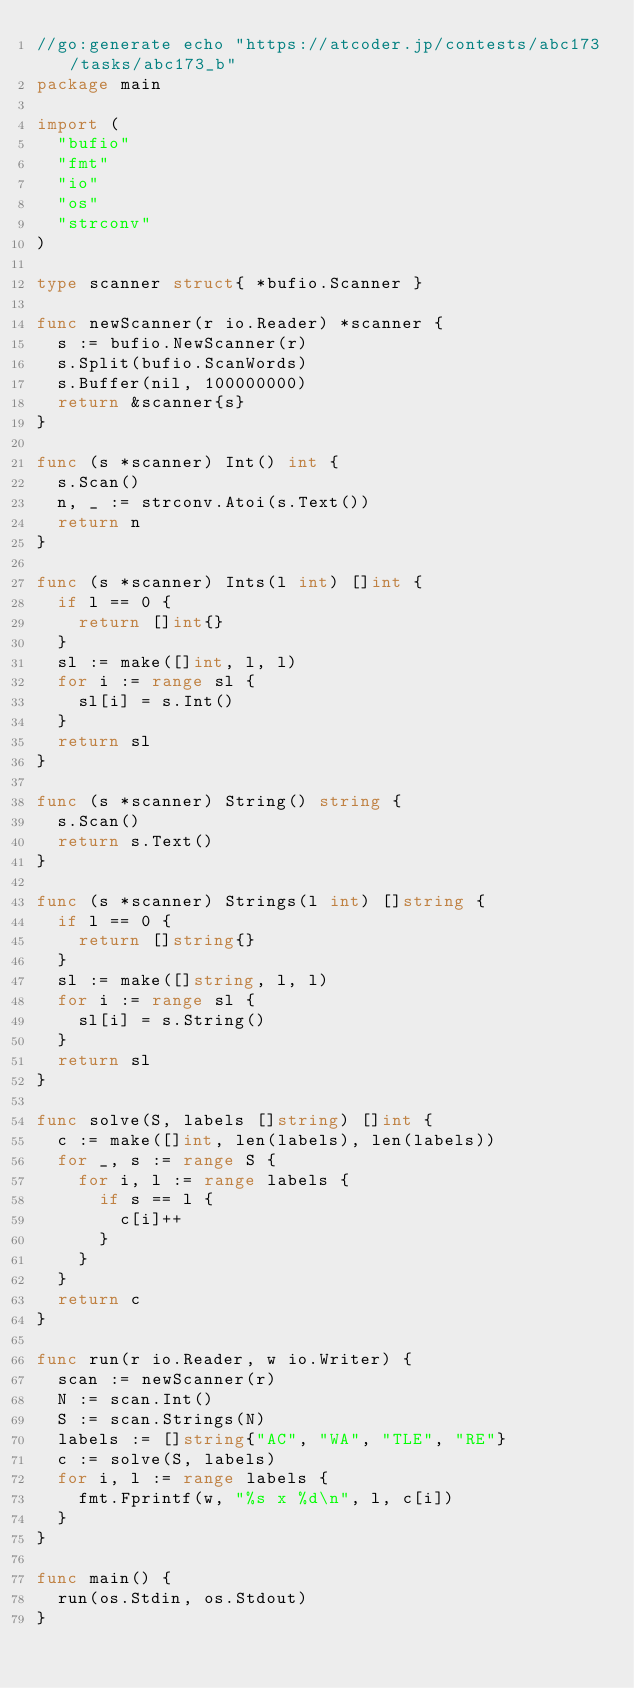Convert code to text. <code><loc_0><loc_0><loc_500><loc_500><_Go_>//go:generate echo "https://atcoder.jp/contests/abc173/tasks/abc173_b"
package main

import (
	"bufio"
	"fmt"
	"io"
	"os"
	"strconv"
)

type scanner struct{ *bufio.Scanner }

func newScanner(r io.Reader) *scanner {
	s := bufio.NewScanner(r)
	s.Split(bufio.ScanWords)
	s.Buffer(nil, 100000000)
	return &scanner{s}
}

func (s *scanner) Int() int {
	s.Scan()
	n, _ := strconv.Atoi(s.Text())
	return n
}

func (s *scanner) Ints(l int) []int {
	if l == 0 {
		return []int{}
	}
	sl := make([]int, l, l)
	for i := range sl {
		sl[i] = s.Int()
	}
	return sl
}

func (s *scanner) String() string {
	s.Scan()
	return s.Text()
}

func (s *scanner) Strings(l int) []string {
	if l == 0 {
		return []string{}
	}
	sl := make([]string, l, l)
	for i := range sl {
		sl[i] = s.String()
	}
	return sl
}

func solve(S, labels []string) []int {
	c := make([]int, len(labels), len(labels))
	for _, s := range S {
		for i, l := range labels {
			if s == l {
				c[i]++
			}
		}
	}
	return c
}

func run(r io.Reader, w io.Writer) {
	scan := newScanner(r)
	N := scan.Int()
	S := scan.Strings(N)
	labels := []string{"AC", "WA", "TLE", "RE"}
	c := solve(S, labels)
	for i, l := range labels {
		fmt.Fprintf(w, "%s x %d\n", l, c[i])
	}
}

func main() {
	run(os.Stdin, os.Stdout)
}
</code> 